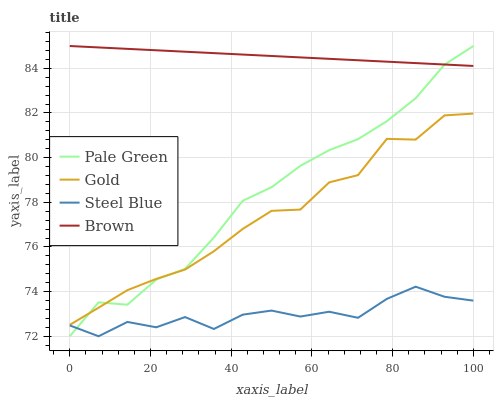Does Steel Blue have the minimum area under the curve?
Answer yes or no. Yes. Does Brown have the maximum area under the curve?
Answer yes or no. Yes. Does Pale Green have the minimum area under the curve?
Answer yes or no. No. Does Pale Green have the maximum area under the curve?
Answer yes or no. No. Is Brown the smoothest?
Answer yes or no. Yes. Is Steel Blue the roughest?
Answer yes or no. Yes. Is Pale Green the smoothest?
Answer yes or no. No. Is Pale Green the roughest?
Answer yes or no. No. Does Pale Green have the lowest value?
Answer yes or no. Yes. Does Gold have the lowest value?
Answer yes or no. No. Does Pale Green have the highest value?
Answer yes or no. Yes. Does Steel Blue have the highest value?
Answer yes or no. No. Is Steel Blue less than Brown?
Answer yes or no. Yes. Is Brown greater than Steel Blue?
Answer yes or no. Yes. Does Steel Blue intersect Pale Green?
Answer yes or no. Yes. Is Steel Blue less than Pale Green?
Answer yes or no. No. Is Steel Blue greater than Pale Green?
Answer yes or no. No. Does Steel Blue intersect Brown?
Answer yes or no. No. 